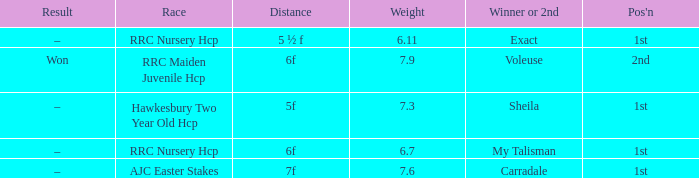What was the distance when the weight was 6.11? 5 ½ f. 